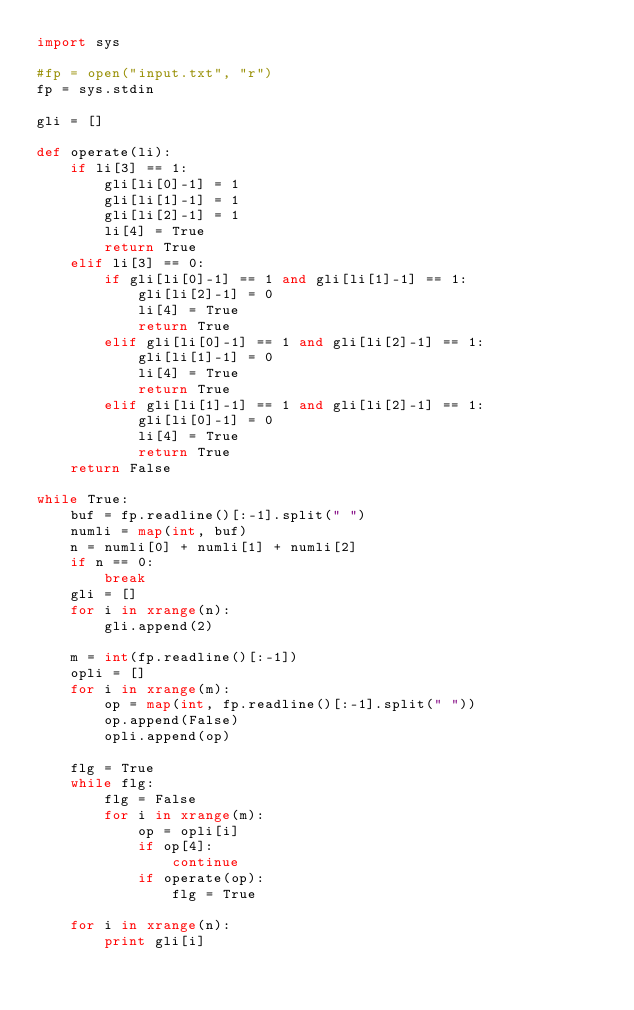<code> <loc_0><loc_0><loc_500><loc_500><_Python_>import sys

#fp = open("input.txt", "r")
fp = sys.stdin

gli = []

def operate(li):
    if li[3] == 1:
        gli[li[0]-1] = 1
        gli[li[1]-1] = 1
        gli[li[2]-1] = 1
        li[4] = True
        return True
    elif li[3] == 0:
        if gli[li[0]-1] == 1 and gli[li[1]-1] == 1:
            gli[li[2]-1] = 0
            li[4] = True
            return True
        elif gli[li[0]-1] == 1 and gli[li[2]-1] == 1:
            gli[li[1]-1] = 0
            li[4] = True
            return True
        elif gli[li[1]-1] == 1 and gli[li[2]-1] == 1:
            gli[li[0]-1] = 0
            li[4] = True
            return True
    return False

while True:
    buf = fp.readline()[:-1].split(" ")
    numli = map(int, buf)
    n = numli[0] + numli[1] + numli[2]
    if n == 0:
        break
    gli = []
    for i in xrange(n):
        gli.append(2)

    m = int(fp.readline()[:-1])
    opli = []
    for i in xrange(m):
        op = map(int, fp.readline()[:-1].split(" "))
        op.append(False)
        opli.append(op)

    flg = True
    while flg:
        flg = False
        for i in xrange(m):
            op = opli[i]
            if op[4]:
                continue
            if operate(op):
                flg = True

    for i in xrange(n):
        print gli[i]</code> 